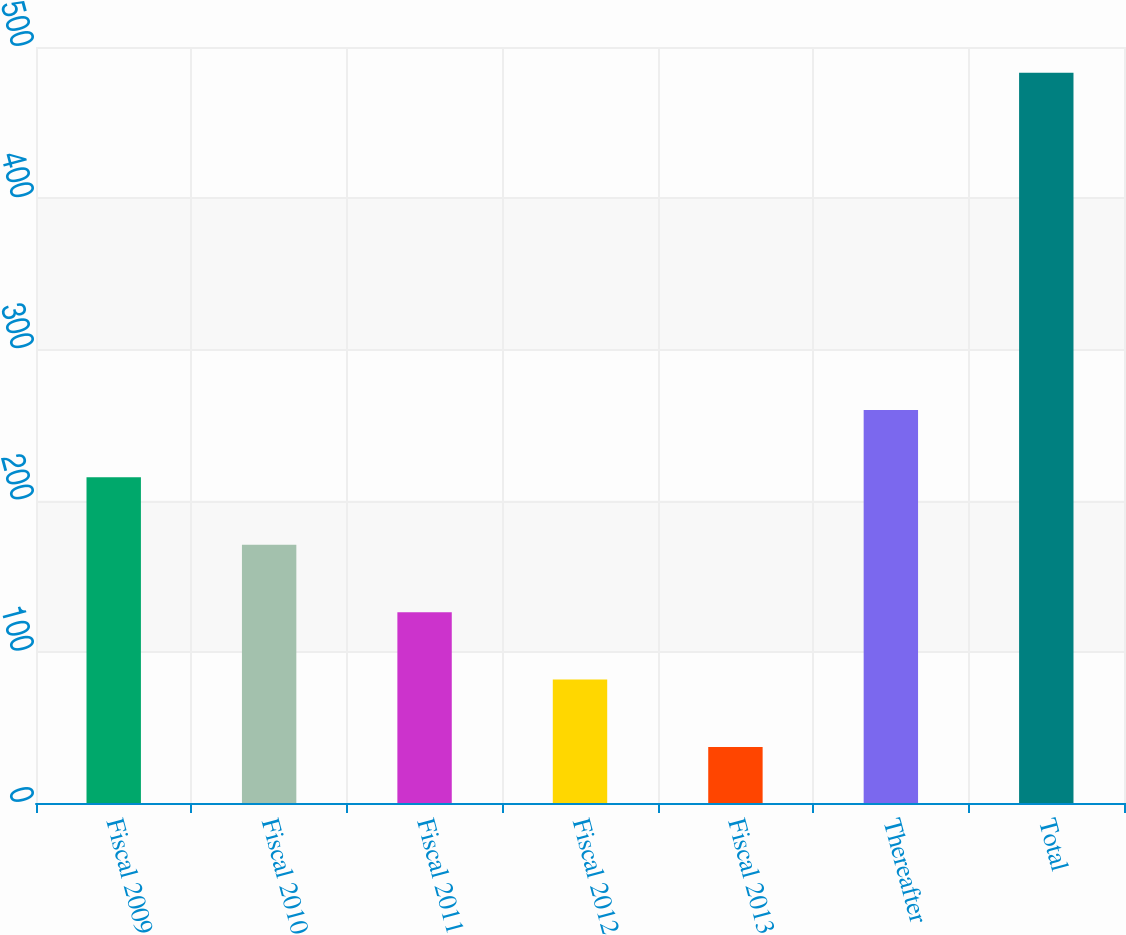<chart> <loc_0><loc_0><loc_500><loc_500><bar_chart><fcel>Fiscal 2009<fcel>Fiscal 2010<fcel>Fiscal 2011<fcel>Fiscal 2012<fcel>Fiscal 2013<fcel>Thereafter<fcel>Total<nl><fcel>215.4<fcel>170.8<fcel>126.2<fcel>81.6<fcel>37<fcel>260<fcel>483<nl></chart> 